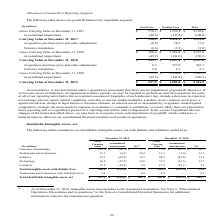According to Sealed Air Corporation's financial document, What does the table show? shows our goodwill balances by reportable segment. The document states: "The following table shows our goodwill balances by reportable segment:..." Also, What are examples of indicator of impairment of goodwill? Examples of such indicators may include a decrease in expected net earnings, adverse equity market conditions, a decline in current market multiples, a decline in our common stock price, a significant adverse change in legal factors or business climates, an adverse action or assessment by a regulator, unanticipated competition, strategic decisions made in response to economic or competitive conditions, or a more likely than not expectation that a reporting unit or a significant portion of a reporting unit will be sold or disposed of.. The document states: "reporting units before the next annual assessment. Examples of such indicators may include a decrease in expected net earnings, adverse equity market ..." Also, What is the impact of a significant adverse impairment of goodwill? we may have to recognize a non-cash impairment of goodwill, which could have a material adverse effect on our consolidated financial condition and results of operations.. The document states: "ant adverse changes of the nature described above, we may have to recognize a non-cash impairment of goodwill, which could have a material adverse eff..." Also, can you calculate: What is the average annual growth rate of Carrying value for Food Care for years 2017-2019? To answer this question, I need to perform calculations using the financial data. The calculation is: [(519.7-526.9)/526.9+(527.9-519.7)/519.7]/2, which equals 0.11 (percentage). This is based on the information: ".0) (190.3) Carrying Value at December 31, 2019 $ 527.9 $ 1,689.0 $ 2,216.9 (In millions) Food Care Product Care Total Gross Carrying Value at December 31, 2017 $ 576.5 $ 1,554.1 $ 2,130.6 .0) (190.2)..." The key data points involved are: 2, 519.7, 526.9. Also, can you calculate: What is Total Accumulated impairment expressed as a percentage of Gross Carrying Value for 2019? Based on the calculation: 190.3/2,407.2, the result is 7.91 (percentage). This is based on the information: "Accumulated impairment (49.3 ) (141.0) (190.3) Carrying Value at December 31, 2019 $ 527.9 $ 1,689.0 $ 2,216.9 ng Value at December 31, 2019 $ 577.2 $ 1,830.0 $ 2,407.2..." The key data points involved are: 190.3, 2,407.2. Also, can you calculate: What is the Average total Carrying Value for years 2017-2019? To answer this question, I need to perform calculations using the financial data. The calculation is: (2,216.9+1,947.6+1,939.8)/3, which equals 2034.77 (in millions). This is based on the information: "ng Value at December 31, 2018 $ 519.7 $ 1,427.9 $ 1,947.6 ng Value at December 31, 2017 $ 526.9 $ 1,412.9 $ 1,939.8 ng Value at December 31, 2019 $ 527.9 $ 1,689.0 $ 2,216.9..." The key data points involved are: 1,939.8, 1,947.6, 2,216.9. 